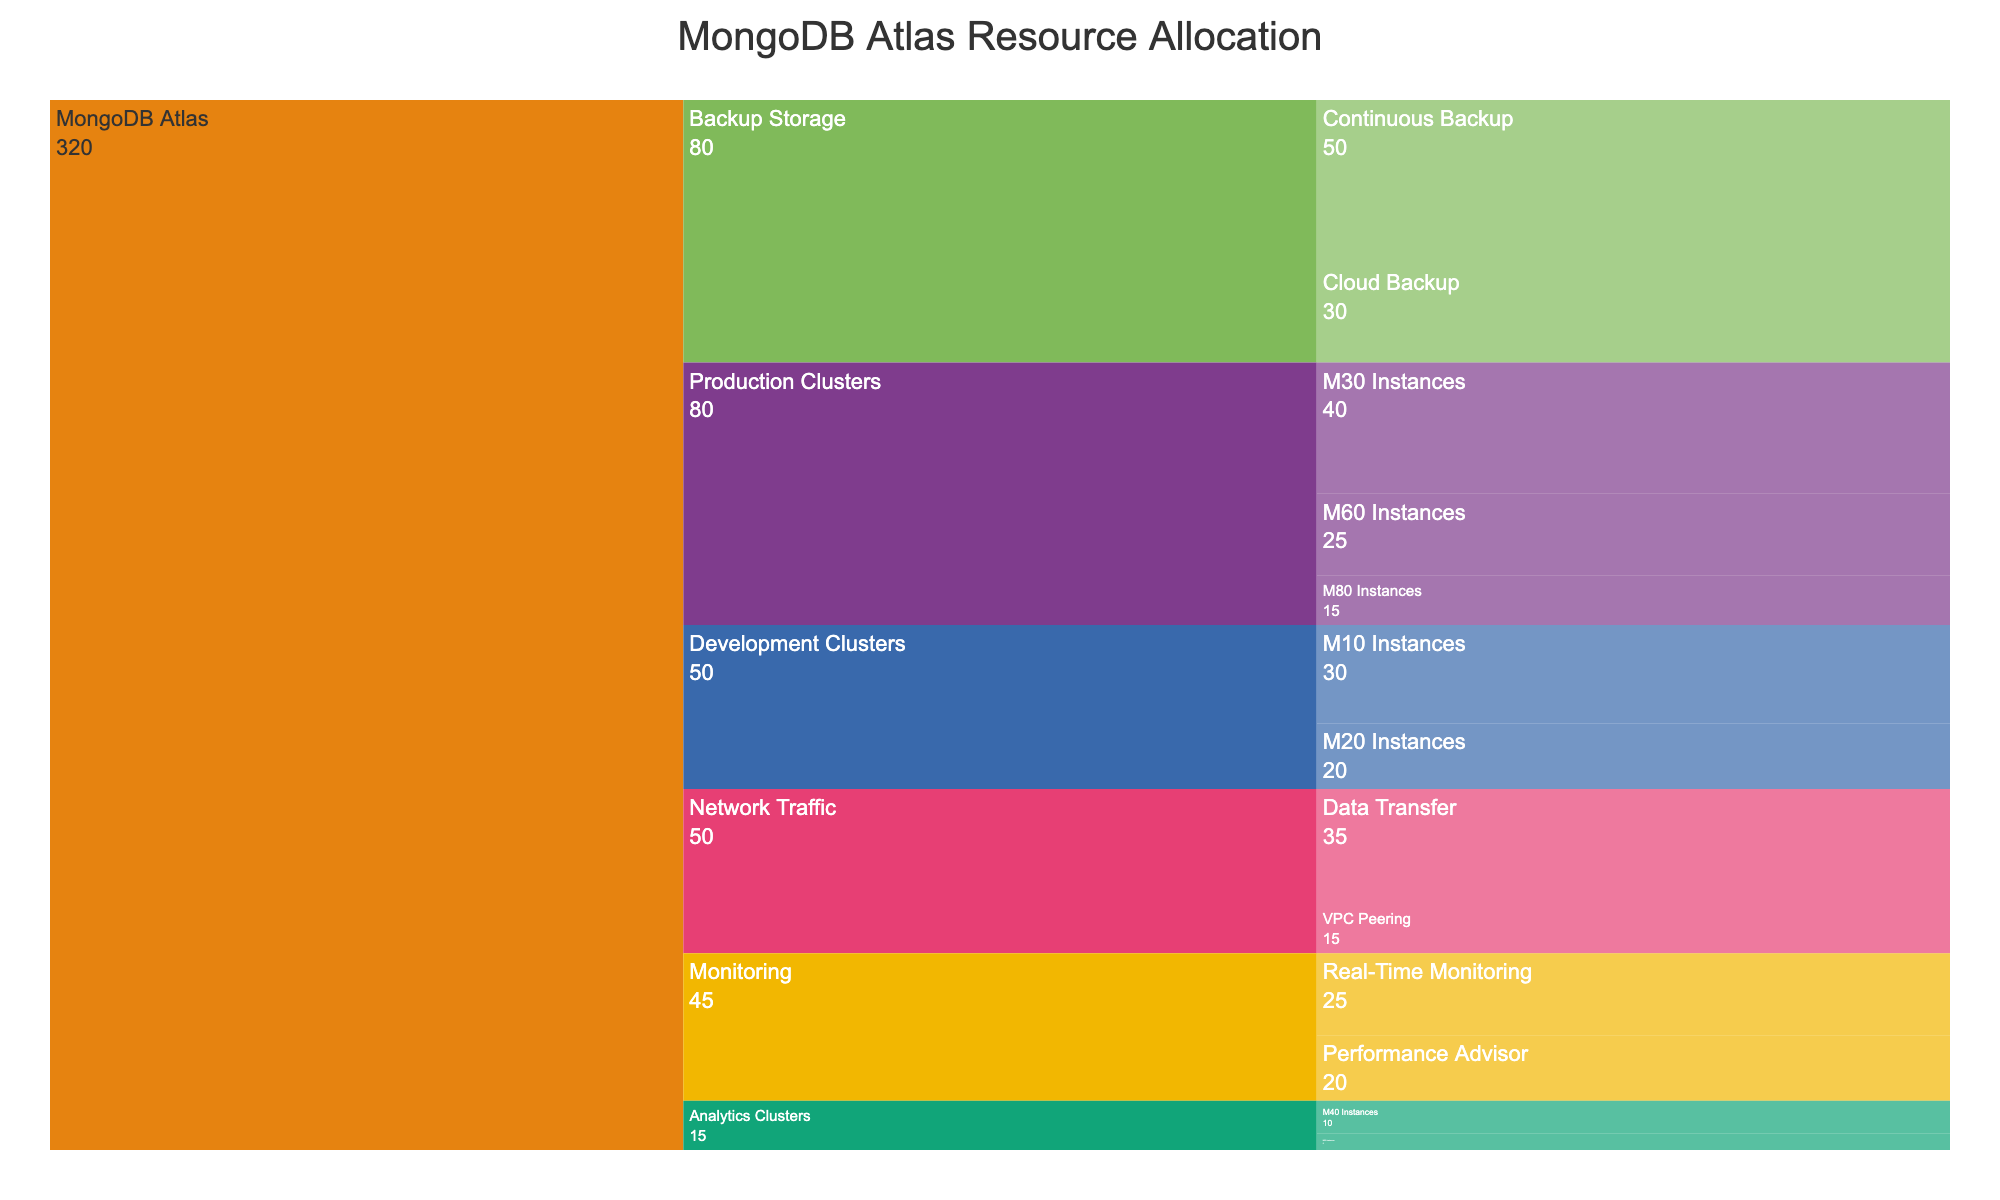What's the title of the figure? The title of the figure is usually displayed prominently at the top of the chart. In this case, it is specified in the code.
Answer: MongoDB Atlas Resource Allocation Which category has the highest resource allocation value? By summing the values in each category, we can determine which one has the highest total.
Answer: Backup Storage What is the total value allocated to Production Clusters? Sum the values of all subcategories within the Production Clusters category: 40 (M30) + 25 (M60) + 15 (M80).
Answer: 80 Which subcategory within Backup Storage has the higher value? Compare the values of the subcategories under Backup Storage: 50 (Continuous Backup) and 30 (Cloud Backup).
Answer: Continuous Backup How much more is allocated to Performance Advisor compared to VPC Peering? Calculate the difference between the values of Performance Advisor and VPC Peering: 20 - 15.
Answer: 5 What is the combined value of the Analytics Clusters category? Sum the values of M40 Instances and M50 Instances under Analytics Clusters: 10 (M40) + 5 (M50).
Answer: 15 Which has a higher combined value: Monitoring or Network Traffic? Sum the values of the subcategories in each category: Network Traffic: 35 (Data Transfer) + 15 (VPC Peering) = 50; Monitoring: 20 (Performance Advisor) + 25 (Real-Time Monitoring) = 45. Compare the two sums.
Answer: Network Traffic How does the value of M10 Instances in Development Clusters compare to M30 Instances in Production Clusters? Directly compare the values: M10 Instances (30) versus M30 Instances (40).
Answer: M10 Instances are 10 units less What's the average value of subcategories within Development Clusters? Sum the values of all subcategories within Development Clusters and divide by the number of subcategories: (30 + 20) / 2.
Answer: 25 Identify the category with the lowest allocation and its value. Look for the category with the smallest sum of its subcategories' values.
Answer: Analytics Clusters, 15 